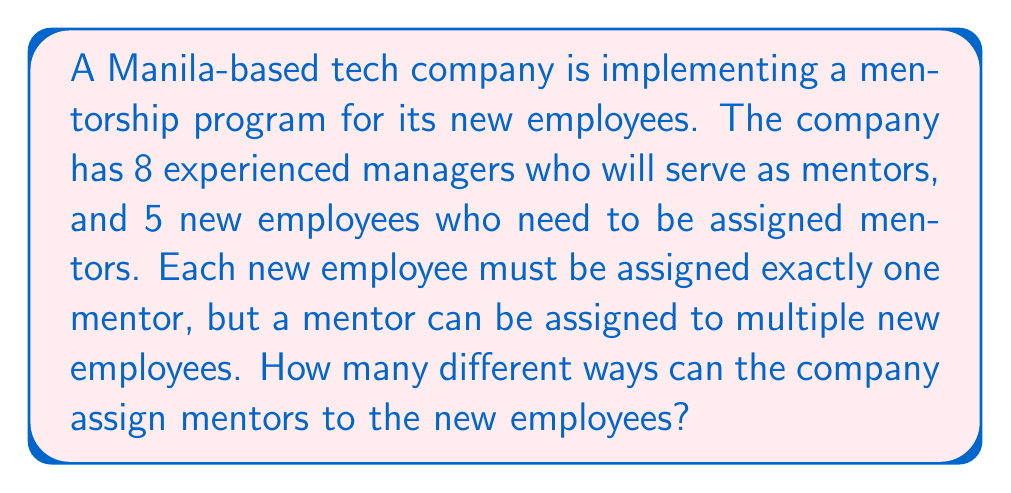Solve this math problem. Let's approach this step-by-step:

1) This is a problem of assigning objects (new employees) to categories (mentors), where each object must be assigned to exactly one category, and categories can have multiple objects.

2) For each new employee, there are 8 possible mentors to choose from.

3) This choice is made independently for each of the 5 new employees.

4) This scenario fits the multiplication principle of counting.

5) According to the multiplication principle, if we have a sequence of $n$ independent choices, where the $i$-th choice has $k_i$ options, the total number of possible outcomes is the product of the number of options for each choice.

6) In this case, we have 5 independent choices (one for each new employee), and each choice has 8 options (the number of mentors).

7) Therefore, the total number of ways to assign mentors is:

   $$8 \times 8 \times 8 \times 8 \times 8 = 8^5$$

8) We can calculate this:

   $$8^5 = 32,768$$

Thus, there are 32,768 different ways to assign mentors to the new employees.
Answer: $32,768$ 